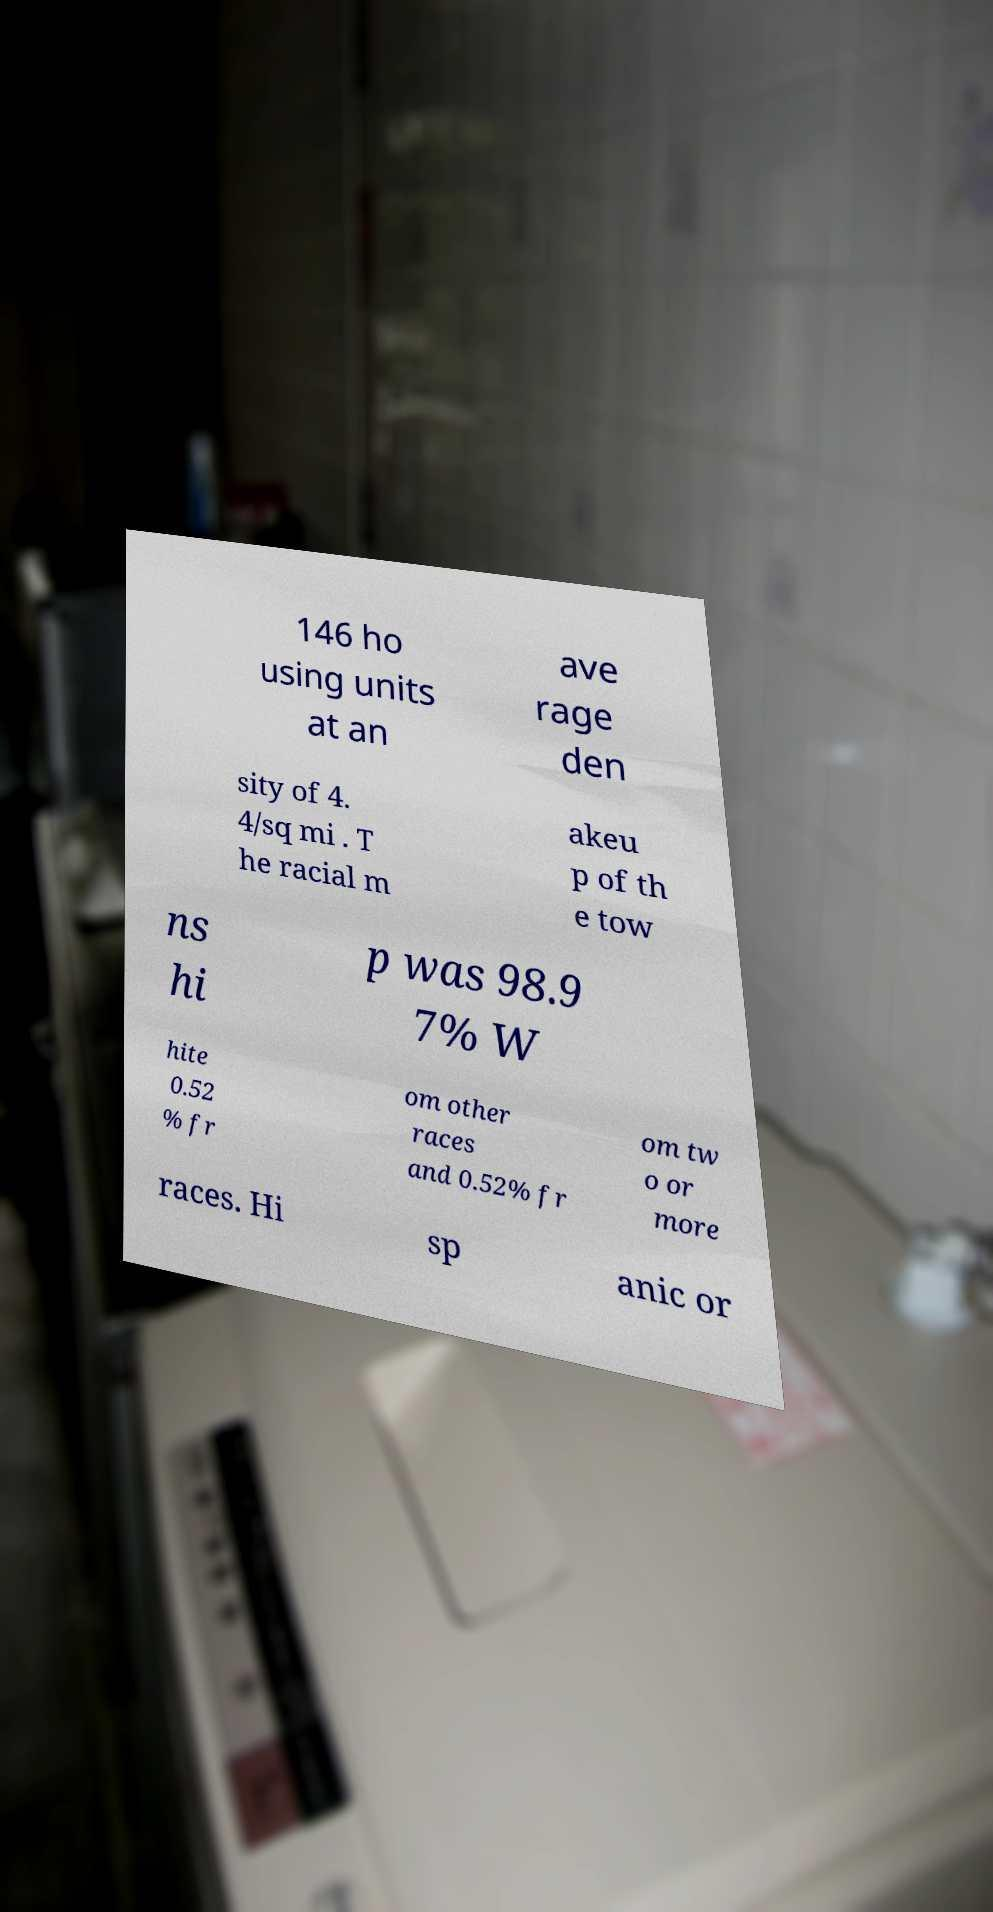Can you accurately transcribe the text from the provided image for me? 146 ho using units at an ave rage den sity of 4. 4/sq mi . T he racial m akeu p of th e tow ns hi p was 98.9 7% W hite 0.52 % fr om other races and 0.52% fr om tw o or more races. Hi sp anic or 